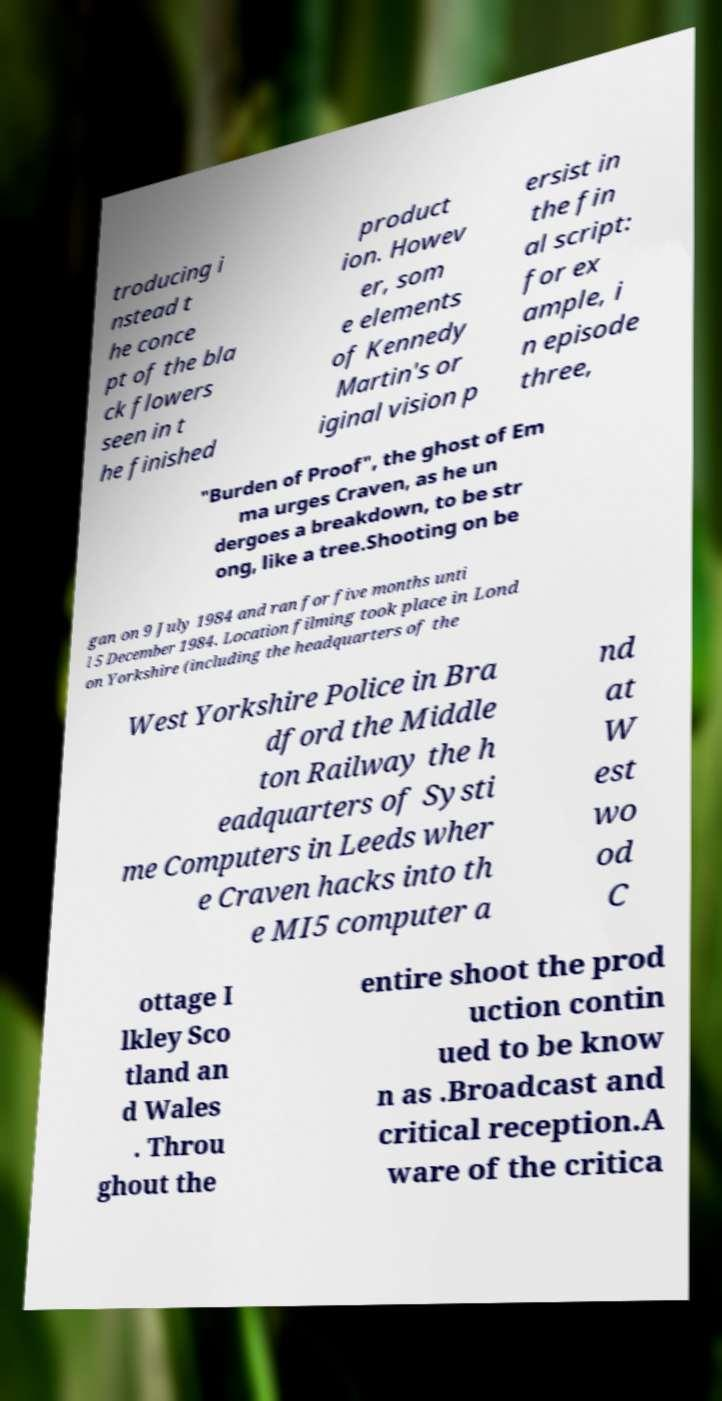Please identify and transcribe the text found in this image. troducing i nstead t he conce pt of the bla ck flowers seen in t he finished product ion. Howev er, som e elements of Kennedy Martin's or iginal vision p ersist in the fin al script: for ex ample, i n episode three, "Burden of Proof", the ghost of Em ma urges Craven, as he un dergoes a breakdown, to be str ong, like a tree.Shooting on be gan on 9 July 1984 and ran for five months unti l 5 December 1984. Location filming took place in Lond on Yorkshire (including the headquarters of the West Yorkshire Police in Bra dford the Middle ton Railway the h eadquarters of Systi me Computers in Leeds wher e Craven hacks into th e MI5 computer a nd at W est wo od C ottage I lkley Sco tland an d Wales . Throu ghout the entire shoot the prod uction contin ued to be know n as .Broadcast and critical reception.A ware of the critica 